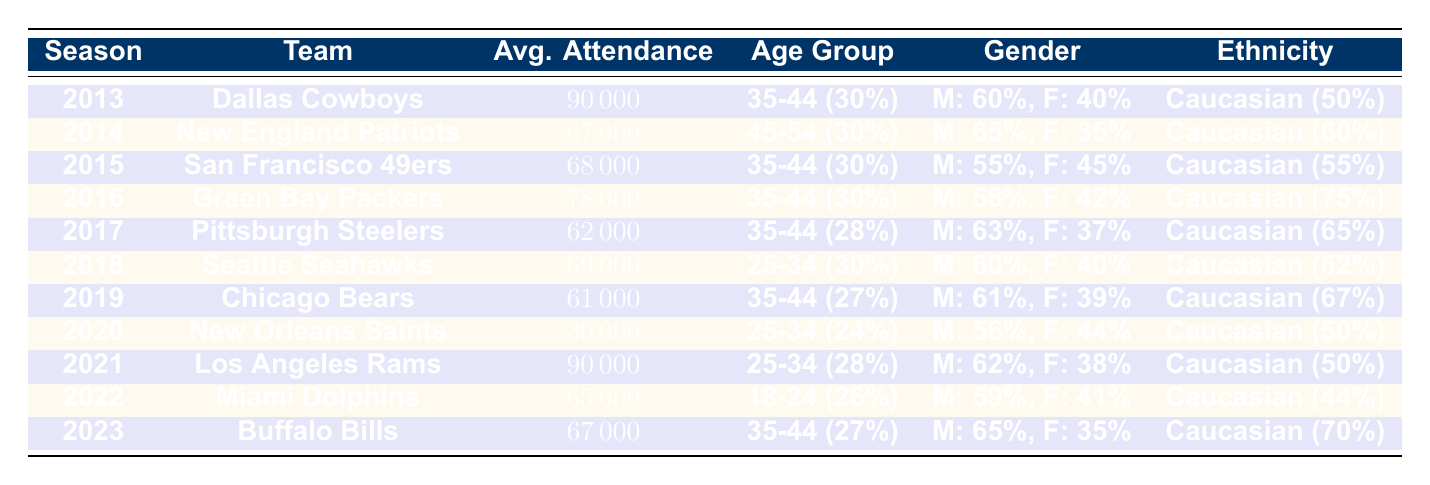What team had the highest average attendance? The highest average attendance is 90,000, which was recorded by the Dallas Cowboys in 2013 and the Los Angeles Rams in 2021.
Answer: Dallas Cowboys and Los Angeles Rams Which age group represented the highest percentage of fans for the Green Bay Packers in 2016? For the Green Bay Packers in 2016, the age group 35-44 represented 30% of the fans, which is the highest percentage among the listed age groups.
Answer: 35-44 In which season did the New Orleans Saints have the lowest average attendance? The New Orleans Saints had the lowest average attendance in 2020 with 30,000.
Answer: 2020 What percentage of fans for the Miami Dolphins in 2022 were female? The female percentage for the Miami Dolphins in 2022 was 41%.
Answer: 41% How many total average attendees were there for teams in the 2013 to 2016 seasons? The total average attendance for the teams from 2013 to 2016 is calculated as 90,000 + 67,000 + 68,000 + 78,000 = 303,000. To find the average, divide by the number of teams (4): 303,000 / 4 = 75,750.
Answer: 75,750 Was the gender distribution of fans for the Buffalo Bills in 2023 balanced? The gender distribution for the Buffalo Bills in 2023 had 65% male and 35% female, indicating a majority male fan base, so it was not balanced.
Answer: No What trend can be observed in average attendance from 2013 to 2023, particularly regarding the years 2020-2021? The trend shows a significant drop in average attendance in 2020 (30,000) likely due to the COVID-19 pandemic, followed by a return to higher attendance levels in 2021 (90,000) with the Los Angeles Rams, suggesting recovery in 2021.
Answer: Significant drop in 2020, recovery in 2021 Which ethnic group had the highest representation among fans of the Pittsburgh Steelers in 2017? The ethnic group with the highest representation among fans of the Pittsburgh Steelers in 2017 was Caucasian, accounting for 65%.
Answer: Caucasian How did the average attendance of the Dallas Cowboys in 2013 compare to that of the Chicago Bears in 2019? The average attendance for the Dallas Cowboys in 2013 was 90,000, whereas the attendance for the Chicago Bears in 2019 was 61,000, showing a difference of 29,000.
Answer: Dallas Cowboys had 29,000 more What was the percentage of fans aged 55 and above for the New Orleans Saints in 2020? For the New Orleans Saints in 2020, the percentage of fans aged 55 and above was 15%.
Answer: 15% 